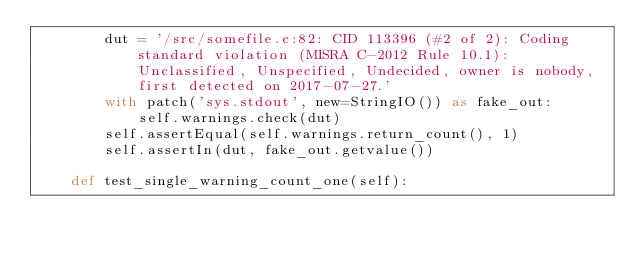<code> <loc_0><loc_0><loc_500><loc_500><_Python_>        dut = '/src/somefile.c:82: CID 113396 (#2 of 2): Coding standard violation (MISRA C-2012 Rule 10.1): Unclassified, Unspecified, Undecided, owner is nobody, first detected on 2017-07-27.'
        with patch('sys.stdout', new=StringIO()) as fake_out:
            self.warnings.check(dut)
        self.assertEqual(self.warnings.return_count(), 1)
        self.assertIn(dut, fake_out.getvalue())

    def test_single_warning_count_one(self):</code> 